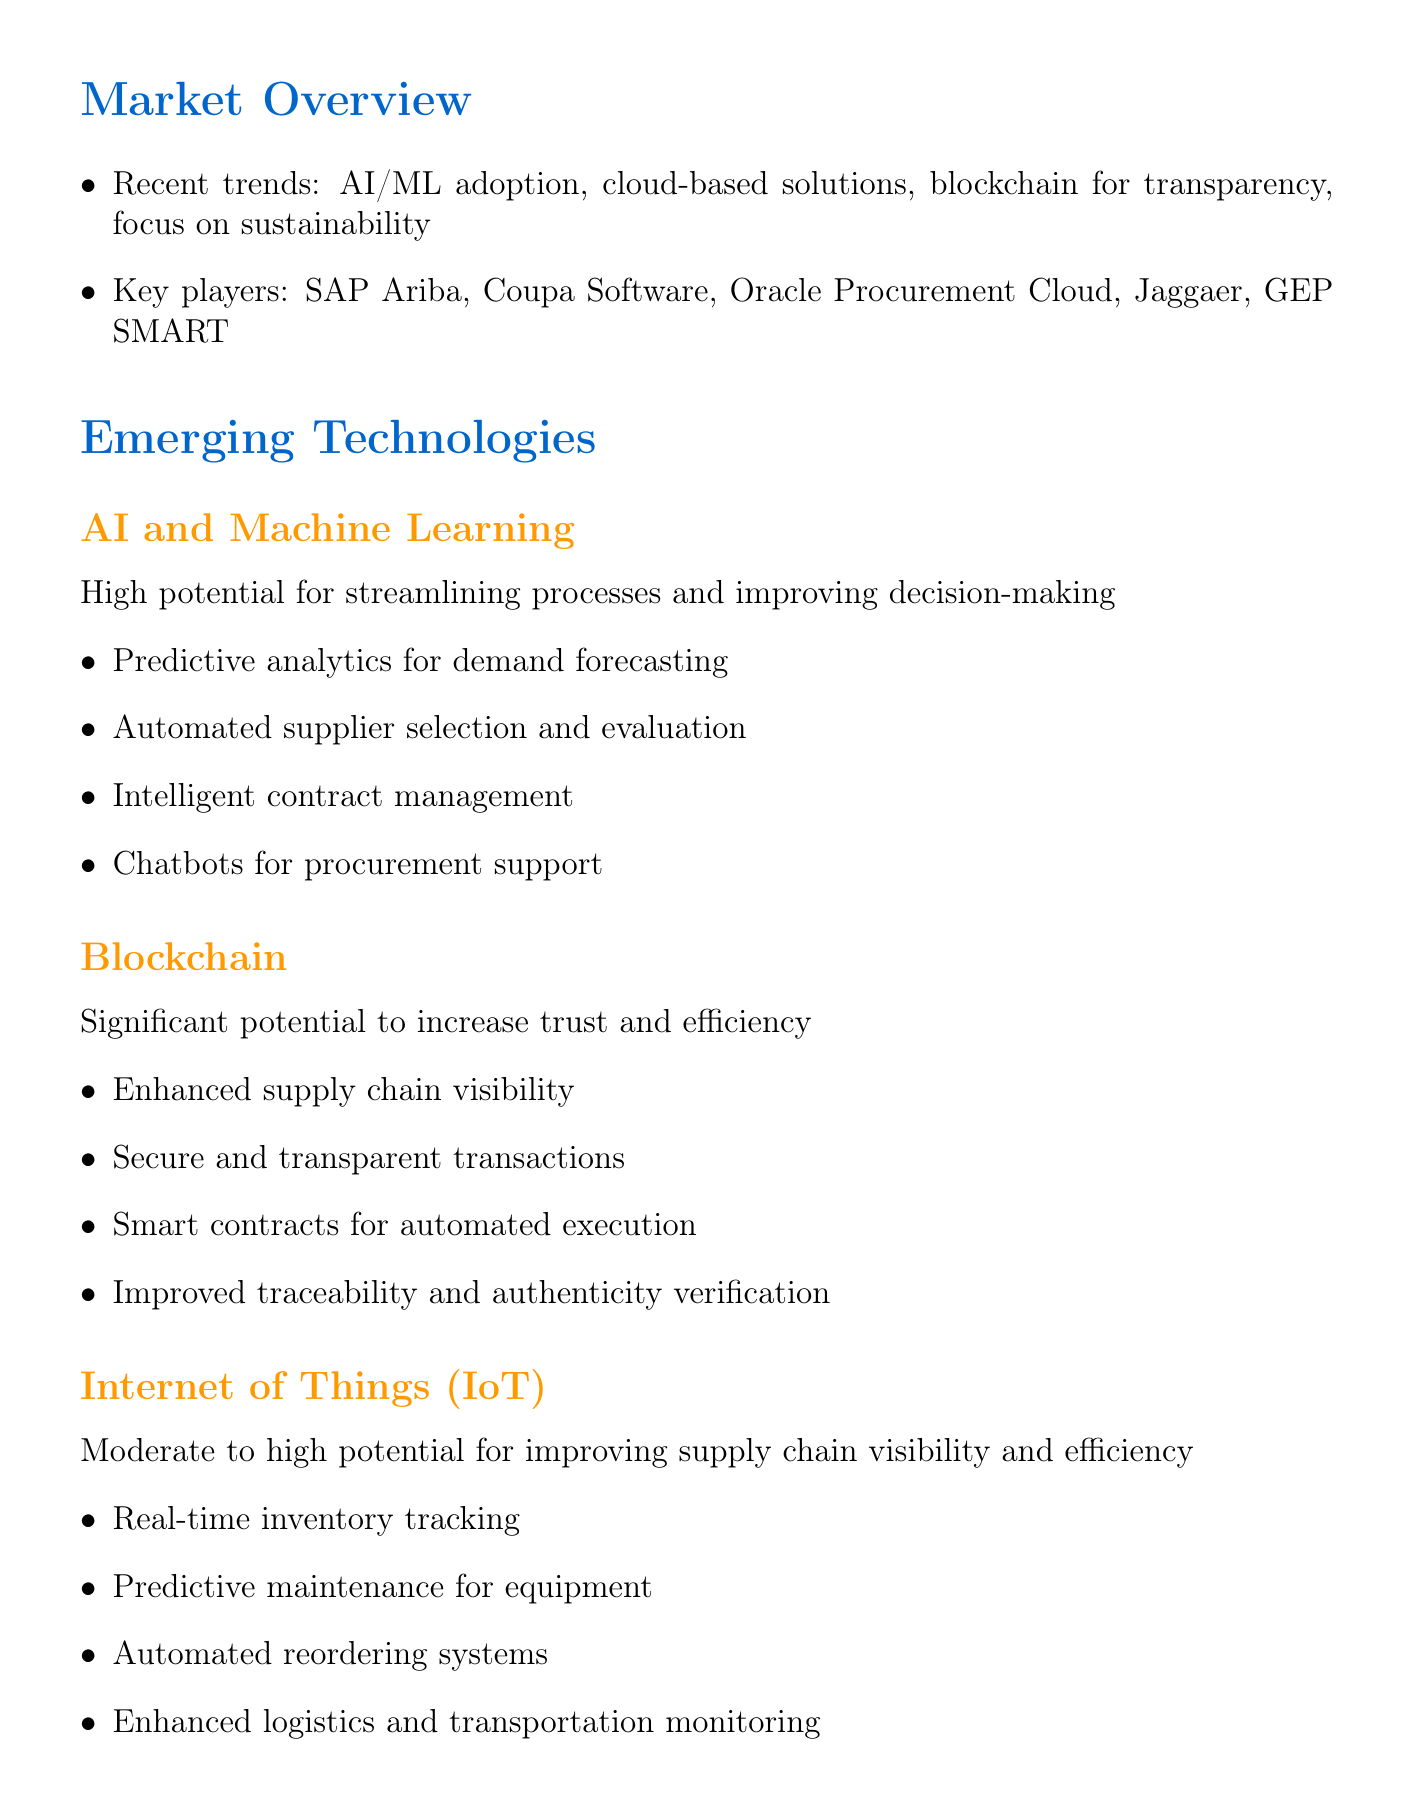what are the recent trends in procurement technology? The recent trends highlighted in the document include AI/ML adoption, cloud-based solutions, blockchain for transparency, and a focus on sustainability.
Answer: AI/ML adoption, cloud-based solutions, blockchain for transparency, sustainability who are the key players in the procurement technology market? The document lists key players in the market, which are SAP Ariba, Coupa Software, Oracle Procurement Cloud, Jaggaer, and GEP SMART.
Answer: SAP Ariba, Coupa Software, Oracle Procurement Cloud, Jaggaer, GEP SMART what is the potential impact of blockchain technology on procurement? The document states that blockchain has significant potential to increase trust and efficiency in procurement.
Answer: Significant potential to increase trust and efficiency what applications does Artificial Intelligence and Machine Learning have in procurement? The document outlines several applications for AI and machine learning including predictive analytics, automated supplier selection, intelligent contract management, and chatbots for procurement support.
Answer: Predictive analytics, automated supplier selection, intelligent contract management, chatbots what strategic action is recommended to enhance user experience in our product offerings? The recommendations section suggests investing in UX/UI improvements and developing mobile applications to enhance user experience.
Answer: Invest in UX/UI improvements and develop mobile applications what challenge is related to the skilled professionals in emerging technologies? The document identifies a shortage of skilled professionals in emerging technologies as a market challenge.
Answer: Shortage of skilled professionals how many recommendations are provided in the memo? The document lists five recommendations for improving product offerings based on market research.
Answer: Five what area does the integration of AI and RPA aim to impact? The document indicates that integrating AI and RPA can significantly reduce operational costs for clients, impacting cost-effectiveness.
Answer: Cost-effectiveness 